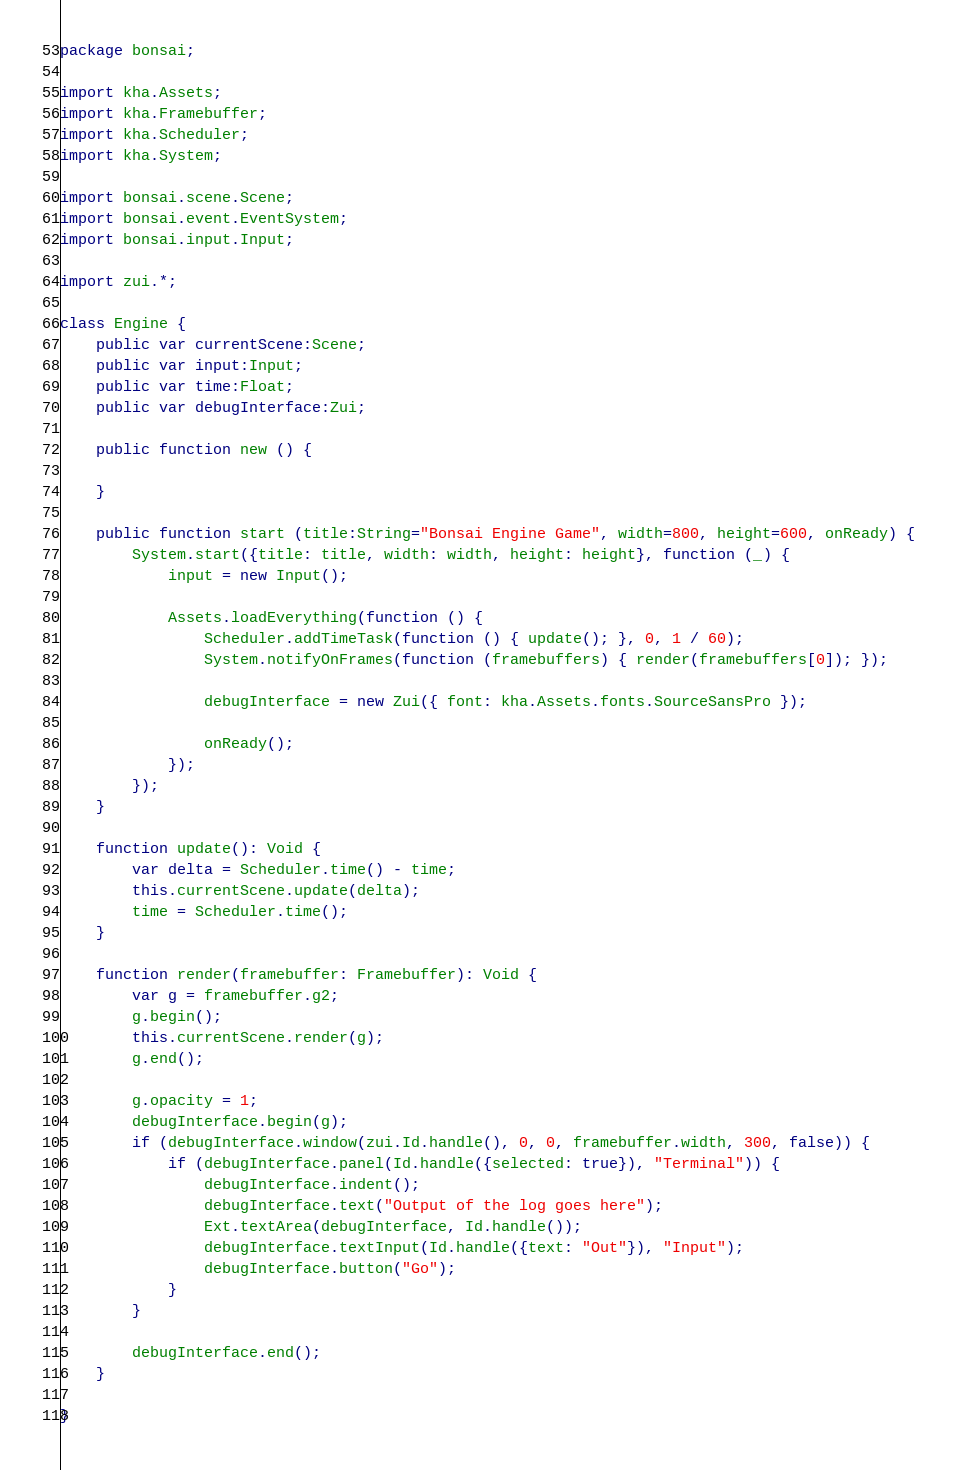<code> <loc_0><loc_0><loc_500><loc_500><_Haxe_>package bonsai;

import kha.Assets;
import kha.Framebuffer;
import kha.Scheduler;
import kha.System;

import bonsai.scene.Scene;
import bonsai.event.EventSystem;
import bonsai.input.Input;

import zui.*;

class Engine {
	public var currentScene:Scene;
	public var input:Input;
	public var time:Float;
	public var debugInterface:Zui;

	public function new () {

	}	

	public function start (title:String="Bonsai Engine Game", width=800, height=600, onReady) {
		System.start({title: title, width: width, height: height}, function (_) {
			input = new Input();

			Assets.loadEverything(function () {
				Scheduler.addTimeTask(function () { update(); }, 0, 1 / 60);
				System.notifyOnFrames(function (framebuffers) { render(framebuffers[0]); });
				
				debugInterface = new Zui({ font: kha.Assets.fonts.SourceSansPro });

				onReady();
			});
		});
	}

	function update(): Void {
		var delta = Scheduler.time() - time;
		this.currentScene.update(delta);
		time = Scheduler.time();
	}

	function render(framebuffer: Framebuffer): Void {
		var g = framebuffer.g2;
		g.begin();
		this.currentScene.render(g);
		g.end();

		g.opacity = 1;
		debugInterface.begin(g);
		if (debugInterface.window(zui.Id.handle(), 0, 0, framebuffer.width, 300, false)) {
			if (debugInterface.panel(Id.handle({selected: true}), "Terminal")) {
				debugInterface.indent();
				debugInterface.text("Output of the log goes here");
				Ext.textArea(debugInterface, Id.handle());
				debugInterface.textInput(Id.handle({text: "Out"}), "Input");
				debugInterface.button("Go");
			}
		}

		debugInterface.end();
	}

}
</code> 